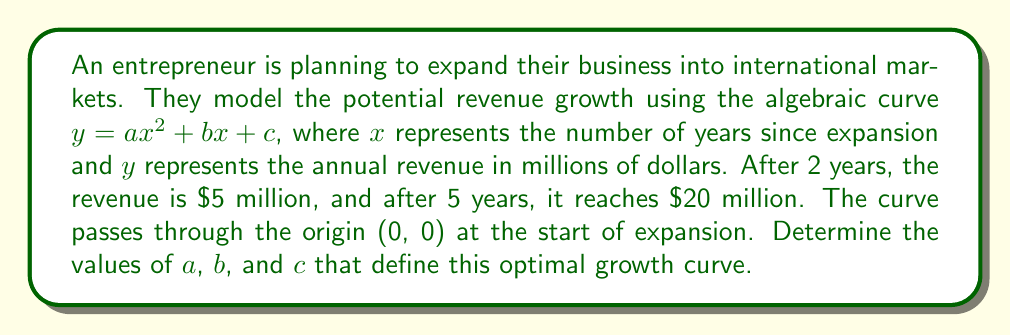Help me with this question. Let's approach this step-by-step:

1) We know that the curve passes through the origin, so when $x = 0$, $y = 0$. This means $c = 0$.

2) Now our equation is $y = ax^2 + bx$

3) We have two more points on the curve:
   When $x = 2$, $y = 5$
   When $x = 5$, $y = 20$

4) Let's create two equations using these points:
   $5 = 4a + 2b$ (Equation 1)
   $20 = 25a + 5b$ (Equation 2)

5) Multiply Equation 1 by 5:
   $25 = 20a + 10b$ (Equation 3)

6) Subtract Equation 3 from Equation 2:
   $-5 = 5a - 5b$
   $1 = b - a$

7) Substitute this into Equation 1:
   $5 = 4a + 2(a + 1)$
   $5 = 6a + 2$
   $3 = 6a$
   $a = 0.5$

8) If $a = 0.5$, then $b = 1.5$

9) Therefore, the optimal growth curve is defined by:
   $y = 0.5x^2 + 1.5x$
Answer: $a = 0.5$, $b = 1.5$, $c = 0$ 